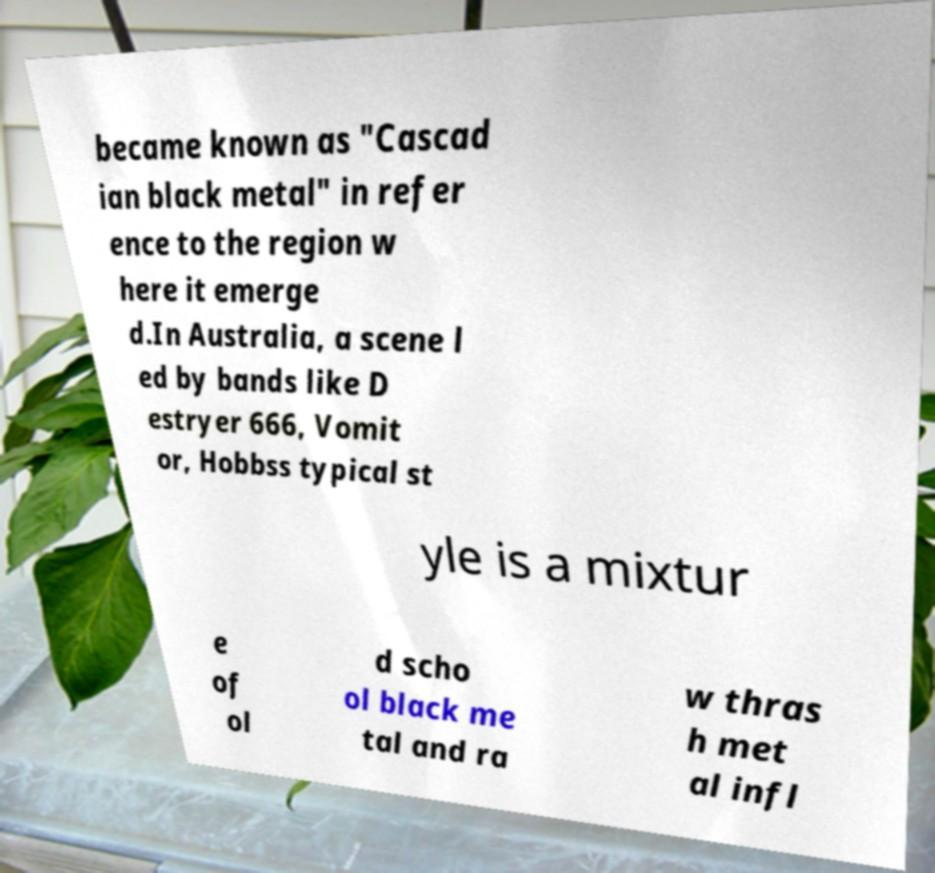Could you extract and type out the text from this image? became known as "Cascad ian black metal" in refer ence to the region w here it emerge d.In Australia, a scene l ed by bands like D estryer 666, Vomit or, Hobbss typical st yle is a mixtur e of ol d scho ol black me tal and ra w thras h met al infl 